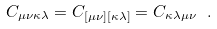<formula> <loc_0><loc_0><loc_500><loc_500>C _ { \mu \nu \kappa \lambda } = C _ { [ \mu \nu ] [ \kappa \lambda ] } = C _ { \kappa \lambda \mu \nu } \ .</formula> 